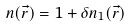<formula> <loc_0><loc_0><loc_500><loc_500>n ( \vec { r } ) = 1 + \delta n _ { 1 } ( \vec { r } )</formula> 